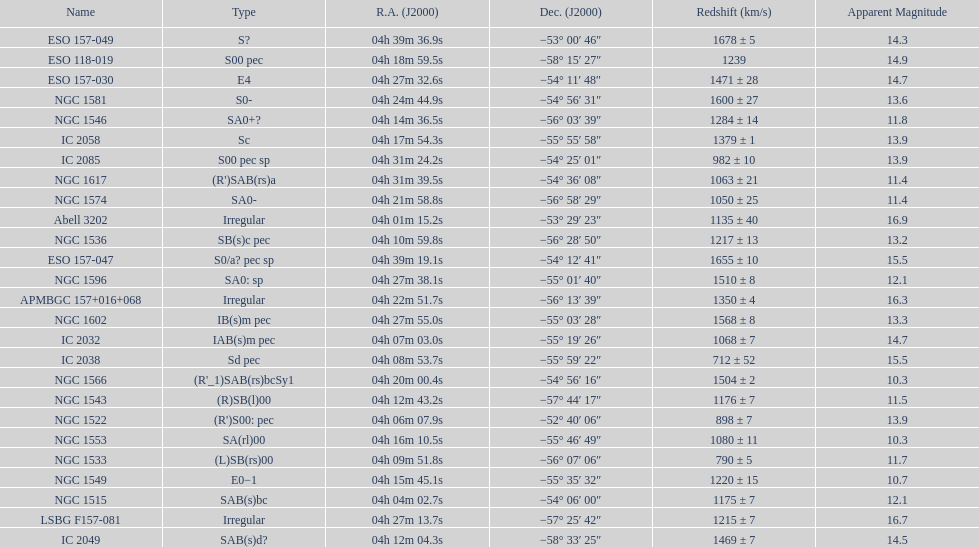Name the member with the highest apparent magnitude. Abell 3202. 